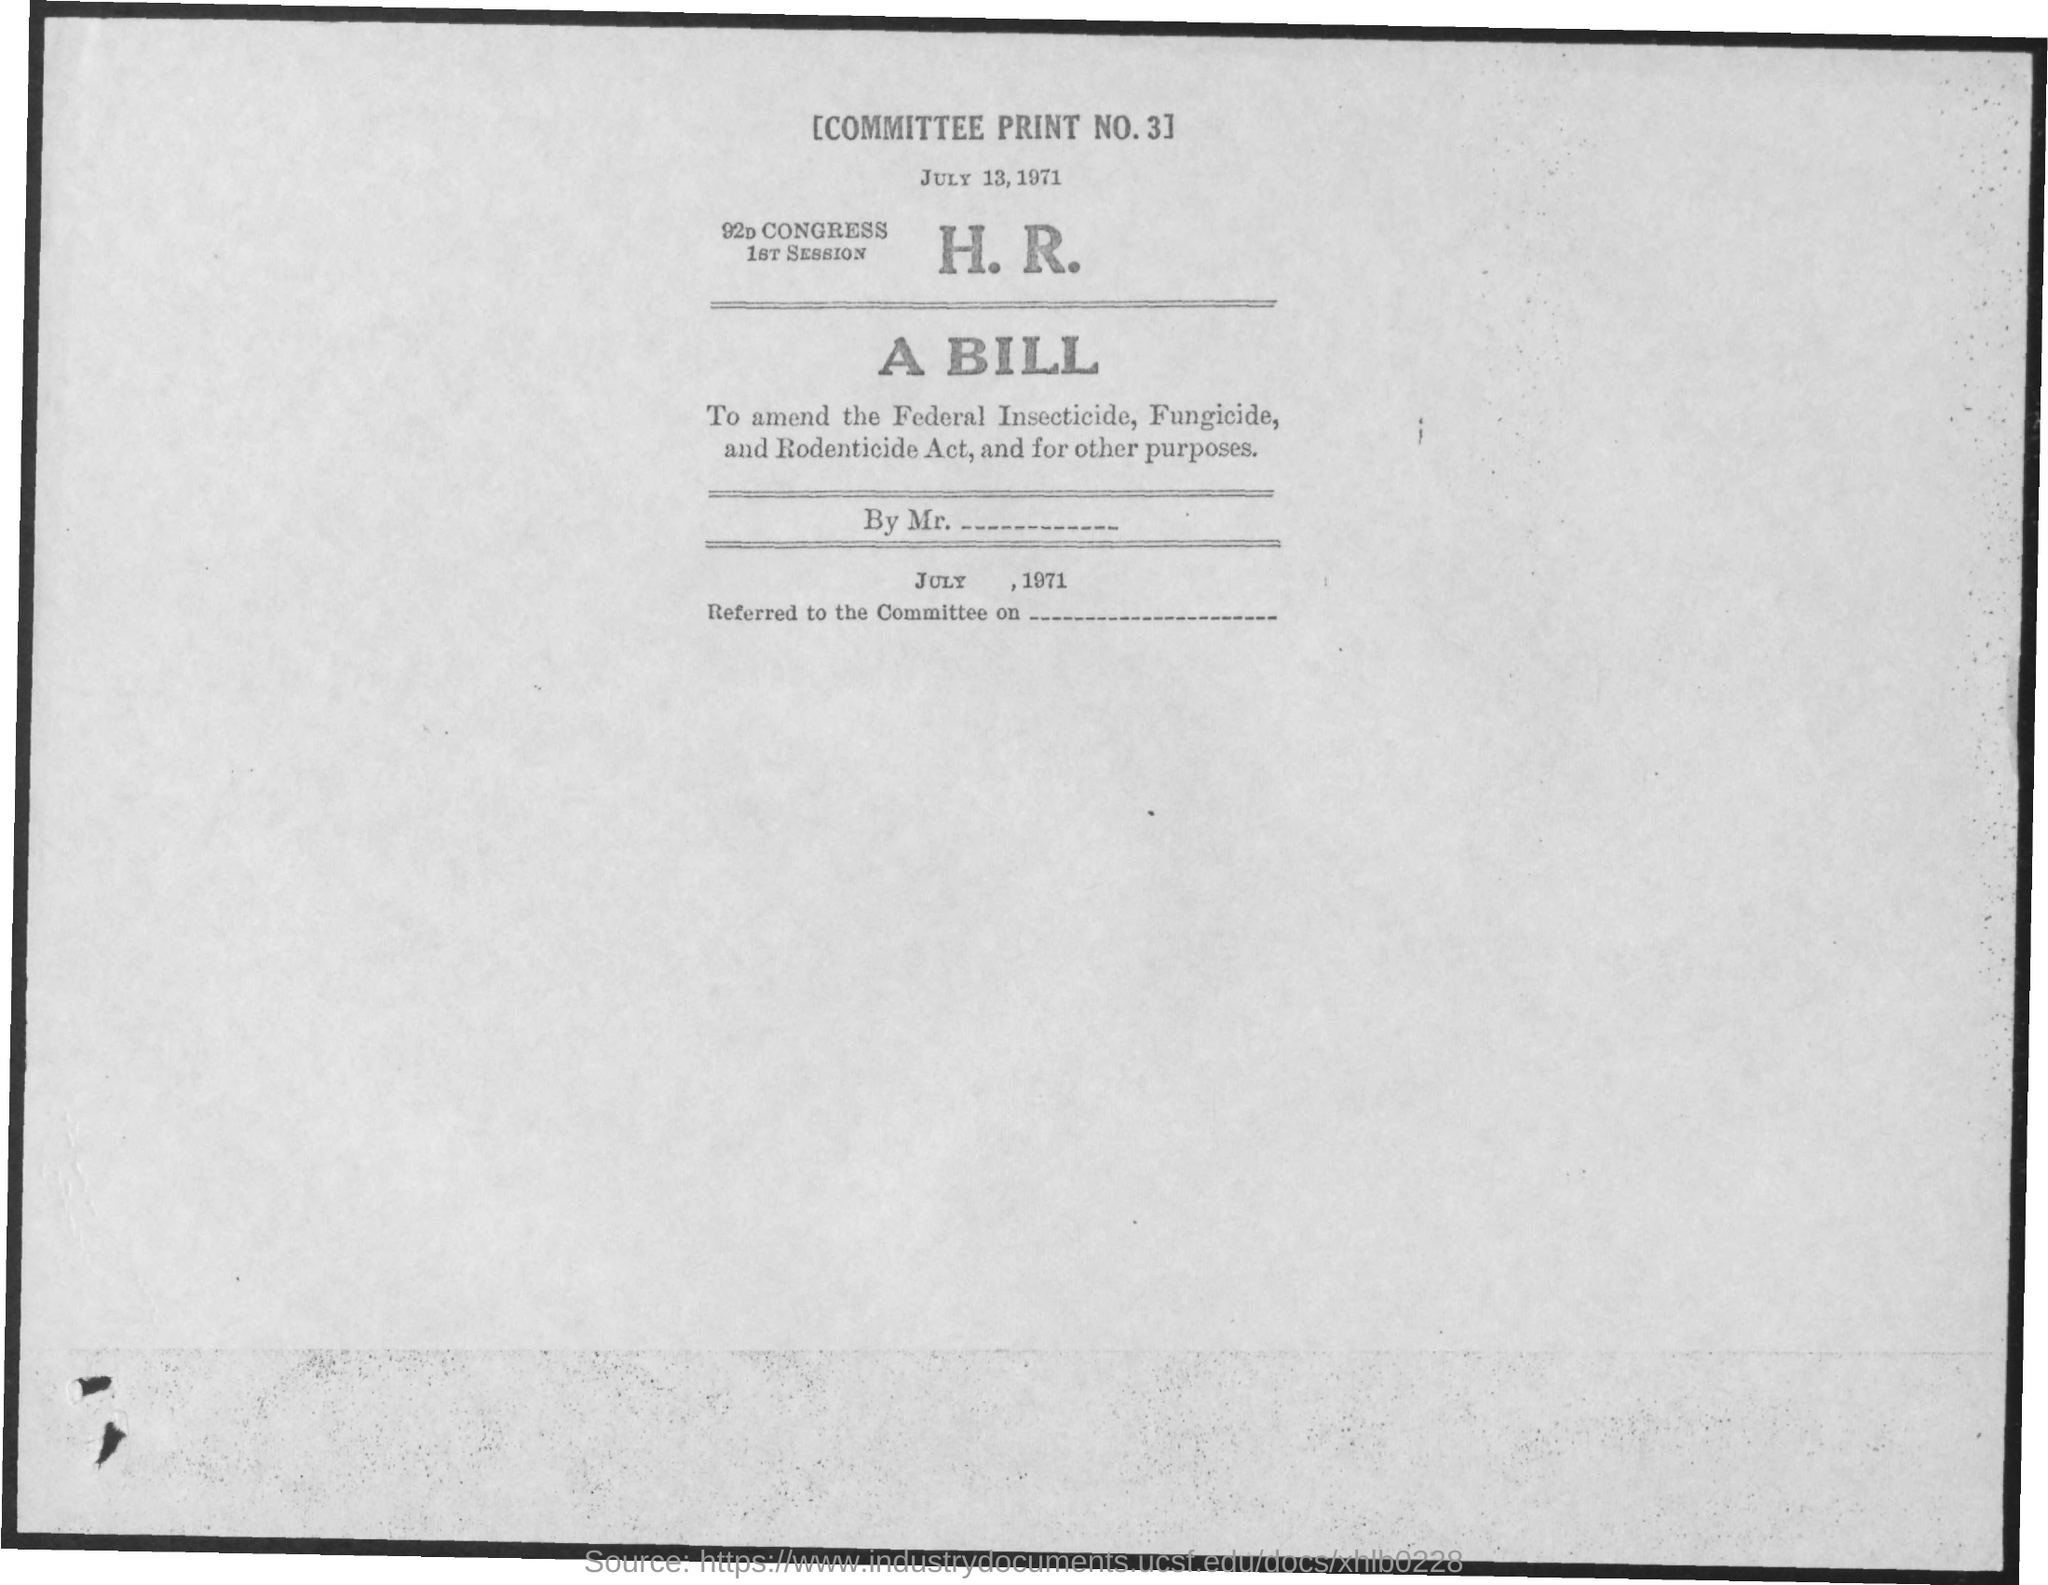Draw attention to some important aspects in this diagram. The document is dated July 13, 1971. What is the committee print number 3.." is a question that inquires about the committee print number. 